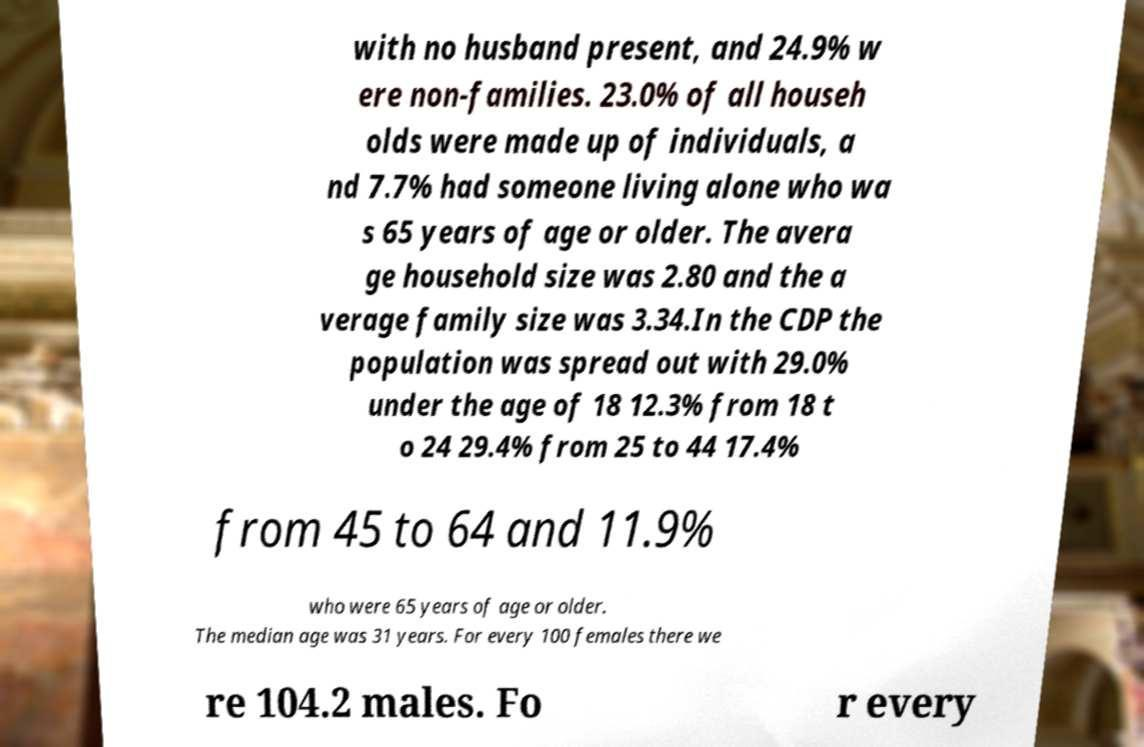Could you extract and type out the text from this image? with no husband present, and 24.9% w ere non-families. 23.0% of all househ olds were made up of individuals, a nd 7.7% had someone living alone who wa s 65 years of age or older. The avera ge household size was 2.80 and the a verage family size was 3.34.In the CDP the population was spread out with 29.0% under the age of 18 12.3% from 18 t o 24 29.4% from 25 to 44 17.4% from 45 to 64 and 11.9% who were 65 years of age or older. The median age was 31 years. For every 100 females there we re 104.2 males. Fo r every 